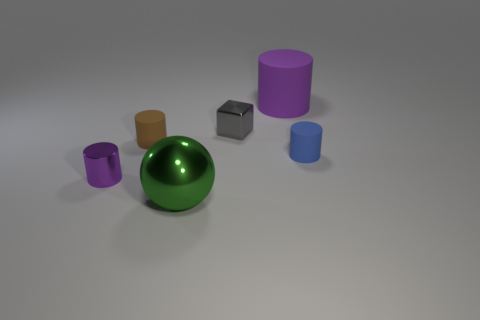Imagine these objects are part of a game. How could they be used? If these objects were part of a game, the cylinders could act as towers or barrels in a stacking challenge, the sphere could be used as a rolling objective to navigate through obstacles, and the cube could serve as a unique piece that fits only in certain places on a game board. 